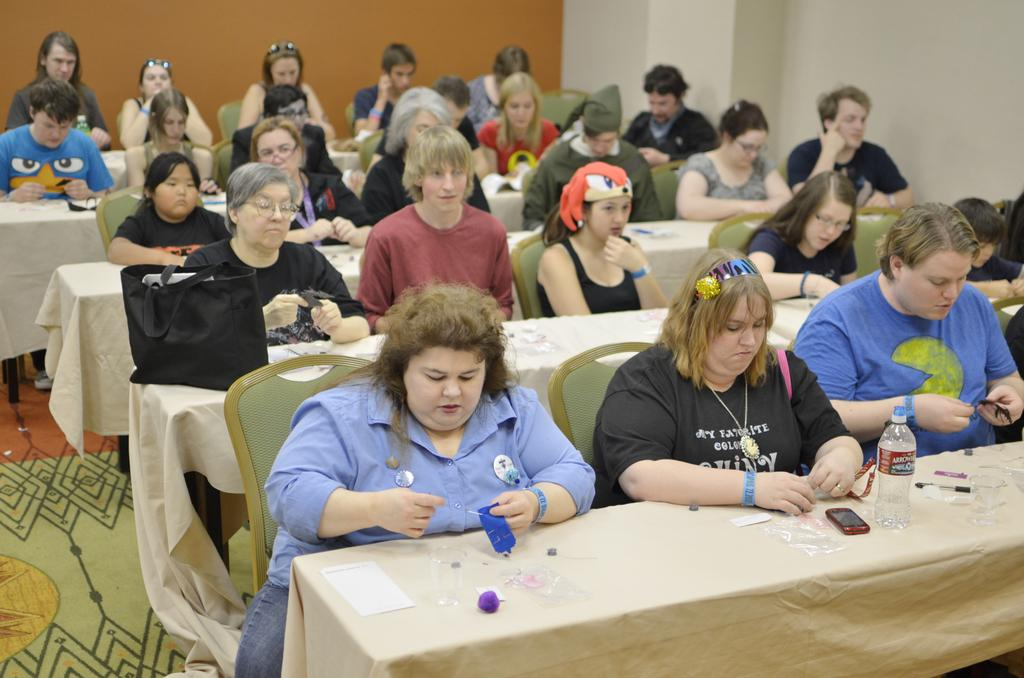How many people are in the image? There are many persons in the image. What are the persons doing in the image? The persons are sitting on chairs. Where are the chairs located in the image? The chairs are at tables. What can be seen in the background of the image? There is a wall in the background of the image. What type of tree can be seen growing through the wall in the image? There is no tree growing through the wall in the image; the background only shows a wall. 